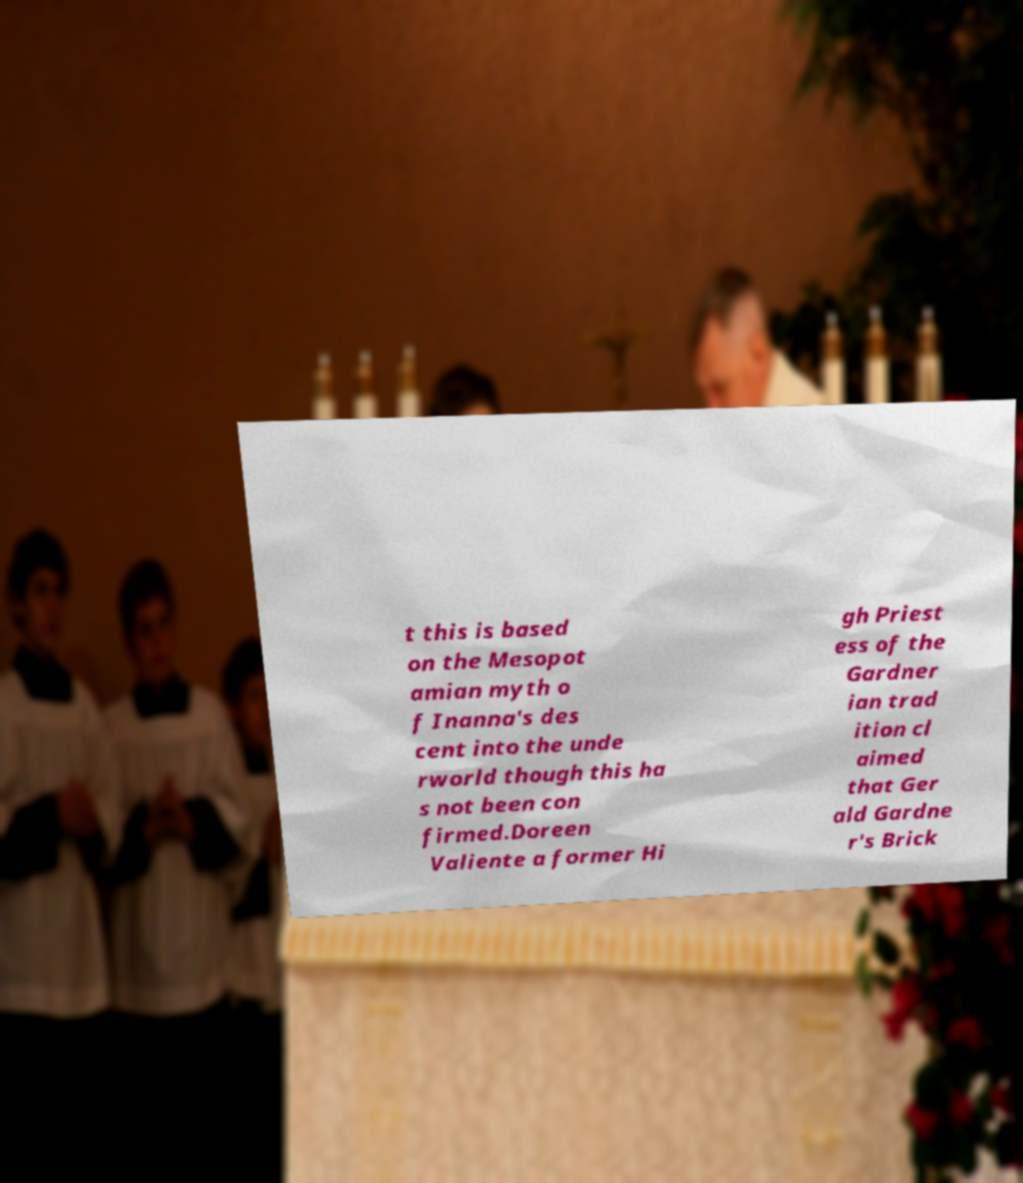Please read and relay the text visible in this image. What does it say? t this is based on the Mesopot amian myth o f Inanna's des cent into the unde rworld though this ha s not been con firmed.Doreen Valiente a former Hi gh Priest ess of the Gardner ian trad ition cl aimed that Ger ald Gardne r's Brick 